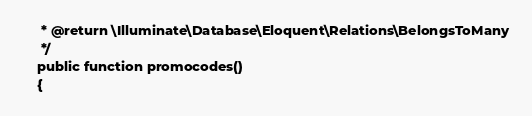<code> <loc_0><loc_0><loc_500><loc_500><_PHP_>     * @return \Illuminate\Database\Eloquent\Relations\BelongsToMany
     */
    public function promocodes()
    {</code> 